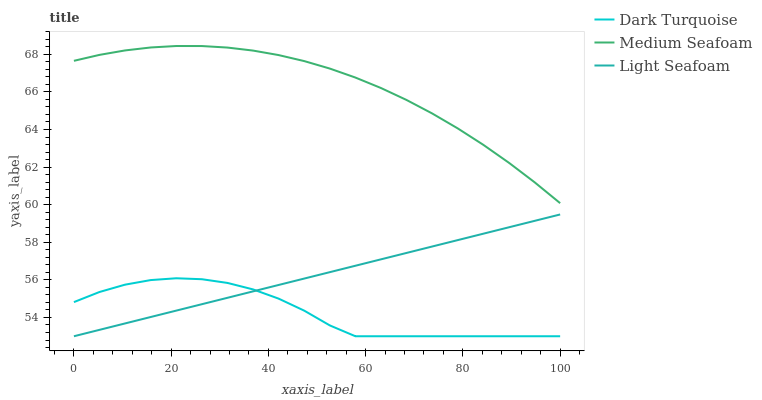Does Dark Turquoise have the minimum area under the curve?
Answer yes or no. Yes. Does Medium Seafoam have the maximum area under the curve?
Answer yes or no. Yes. Does Light Seafoam have the minimum area under the curve?
Answer yes or no. No. Does Light Seafoam have the maximum area under the curve?
Answer yes or no. No. Is Light Seafoam the smoothest?
Answer yes or no. Yes. Is Dark Turquoise the roughest?
Answer yes or no. Yes. Is Medium Seafoam the smoothest?
Answer yes or no. No. Is Medium Seafoam the roughest?
Answer yes or no. No. Does Dark Turquoise have the lowest value?
Answer yes or no. Yes. Does Medium Seafoam have the lowest value?
Answer yes or no. No. Does Medium Seafoam have the highest value?
Answer yes or no. Yes. Does Light Seafoam have the highest value?
Answer yes or no. No. Is Dark Turquoise less than Medium Seafoam?
Answer yes or no. Yes. Is Medium Seafoam greater than Dark Turquoise?
Answer yes or no. Yes. Does Dark Turquoise intersect Light Seafoam?
Answer yes or no. Yes. Is Dark Turquoise less than Light Seafoam?
Answer yes or no. No. Is Dark Turquoise greater than Light Seafoam?
Answer yes or no. No. Does Dark Turquoise intersect Medium Seafoam?
Answer yes or no. No. 